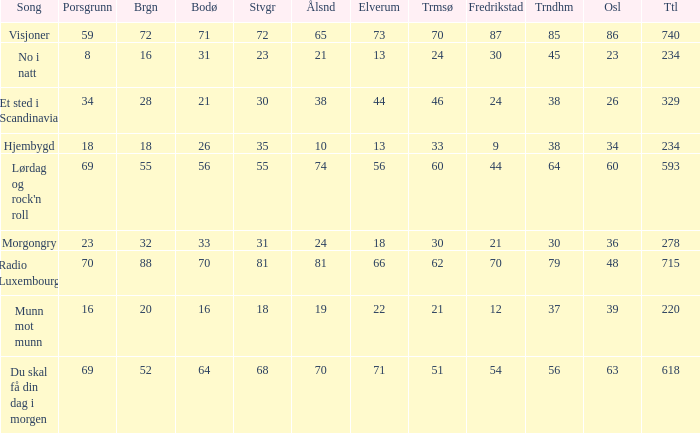When bergen is 88, what is the alesund? 81.0. Parse the full table. {'header': ['Song', 'Porsgrunn', 'Brgn', 'Bodø', 'Stvgr', 'Ålsnd', 'Elverum', 'Trmsø', 'Fredrikstad', 'Trndhm', 'Osl', 'Ttl'], 'rows': [['Visjoner', '59', '72', '71', '72', '65', '73', '70', '87', '85', '86', '740'], ['No i natt', '8', '16', '31', '23', '21', '13', '24', '30', '45', '23', '234'], ['Et sted i Scandinavia', '34', '28', '21', '30', '38', '44', '46', '24', '38', '26', '329'], ['Hjembygd', '18', '18', '26', '35', '10', '13', '33', '9', '38', '34', '234'], ["Lørdag og rock'n roll", '69', '55', '56', '55', '74', '56', '60', '44', '64', '60', '593'], ['Morgongry', '23', '32', '33', '31', '24', '18', '30', '21', '30', '36', '278'], ['Radio Luxembourg', '70', '88', '70', '81', '81', '66', '62', '70', '79', '48', '715'], ['Munn mot munn', '16', '20', '16', '18', '19', '22', '21', '12', '37', '39', '220'], ['Du skal få din dag i morgen', '69', '52', '64', '68', '70', '71', '51', '54', '56', '63', '618']]} 